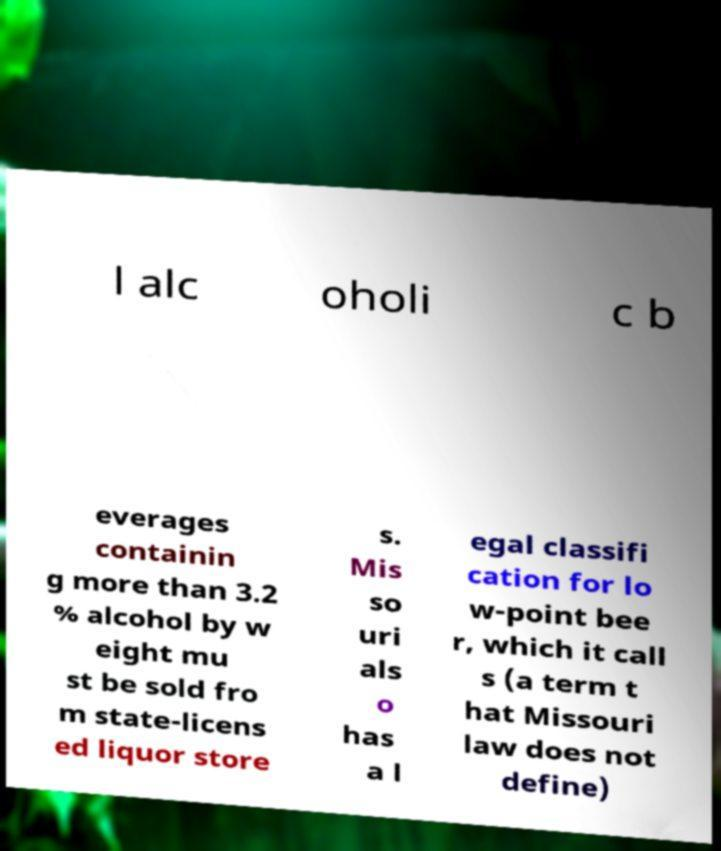There's text embedded in this image that I need extracted. Can you transcribe it verbatim? l alc oholi c b everages containin g more than 3.2 % alcohol by w eight mu st be sold fro m state-licens ed liquor store s. Mis so uri als o has a l egal classifi cation for lo w-point bee r, which it call s (a term t hat Missouri law does not define) 